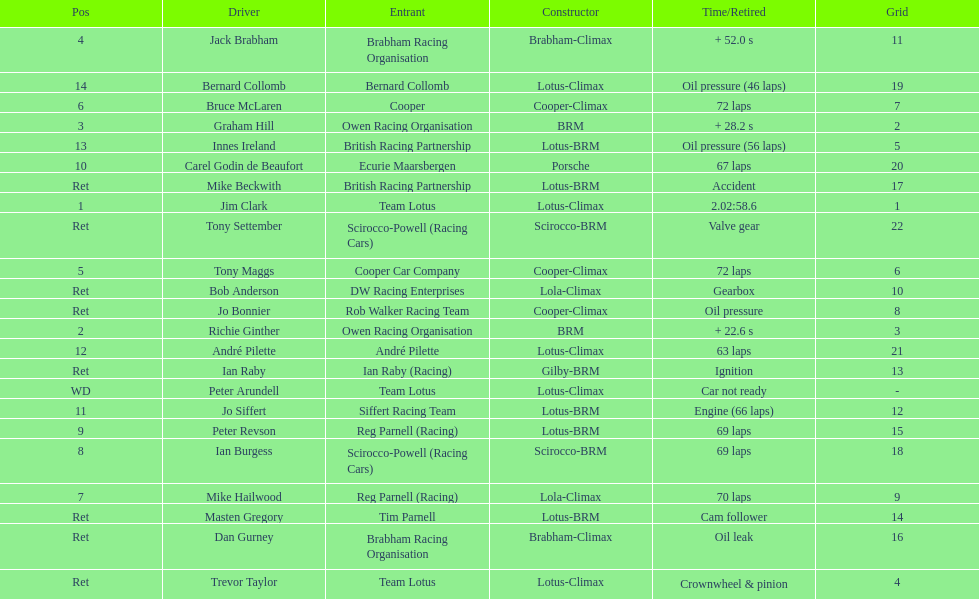Who came in first? Jim Clark. Write the full table. {'header': ['Pos', 'Driver', 'Entrant', 'Constructor', 'Time/Retired', 'Grid'], 'rows': [['4', 'Jack Brabham', 'Brabham Racing Organisation', 'Brabham-Climax', '+ 52.0 s', '11'], ['14', 'Bernard Collomb', 'Bernard Collomb', 'Lotus-Climax', 'Oil pressure (46 laps)', '19'], ['6', 'Bruce McLaren', 'Cooper', 'Cooper-Climax', '72 laps', '7'], ['3', 'Graham Hill', 'Owen Racing Organisation', 'BRM', '+ 28.2 s', '2'], ['13', 'Innes Ireland', 'British Racing Partnership', 'Lotus-BRM', 'Oil pressure (56 laps)', '5'], ['10', 'Carel Godin de Beaufort', 'Ecurie Maarsbergen', 'Porsche', '67 laps', '20'], ['Ret', 'Mike Beckwith', 'British Racing Partnership', 'Lotus-BRM', 'Accident', '17'], ['1', 'Jim Clark', 'Team Lotus', 'Lotus-Climax', '2.02:58.6', '1'], ['Ret', 'Tony Settember', 'Scirocco-Powell (Racing Cars)', 'Scirocco-BRM', 'Valve gear', '22'], ['5', 'Tony Maggs', 'Cooper Car Company', 'Cooper-Climax', '72 laps', '6'], ['Ret', 'Bob Anderson', 'DW Racing Enterprises', 'Lola-Climax', 'Gearbox', '10'], ['Ret', 'Jo Bonnier', 'Rob Walker Racing Team', 'Cooper-Climax', 'Oil pressure', '8'], ['2', 'Richie Ginther', 'Owen Racing Organisation', 'BRM', '+ 22.6 s', '3'], ['12', 'André Pilette', 'André Pilette', 'Lotus-Climax', '63 laps', '21'], ['Ret', 'Ian Raby', 'Ian Raby (Racing)', 'Gilby-BRM', 'Ignition', '13'], ['WD', 'Peter Arundell', 'Team Lotus', 'Lotus-Climax', 'Car not ready', '-'], ['11', 'Jo Siffert', 'Siffert Racing Team', 'Lotus-BRM', 'Engine (66 laps)', '12'], ['9', 'Peter Revson', 'Reg Parnell (Racing)', 'Lotus-BRM', '69 laps', '15'], ['8', 'Ian Burgess', 'Scirocco-Powell (Racing Cars)', 'Scirocco-BRM', '69 laps', '18'], ['7', 'Mike Hailwood', 'Reg Parnell (Racing)', 'Lola-Climax', '70 laps', '9'], ['Ret', 'Masten Gregory', 'Tim Parnell', 'Lotus-BRM', 'Cam follower', '14'], ['Ret', 'Dan Gurney', 'Brabham Racing Organisation', 'Brabham-Climax', 'Oil leak', '16'], ['Ret', 'Trevor Taylor', 'Team Lotus', 'Lotus-Climax', 'Crownwheel & pinion', '4']]} 